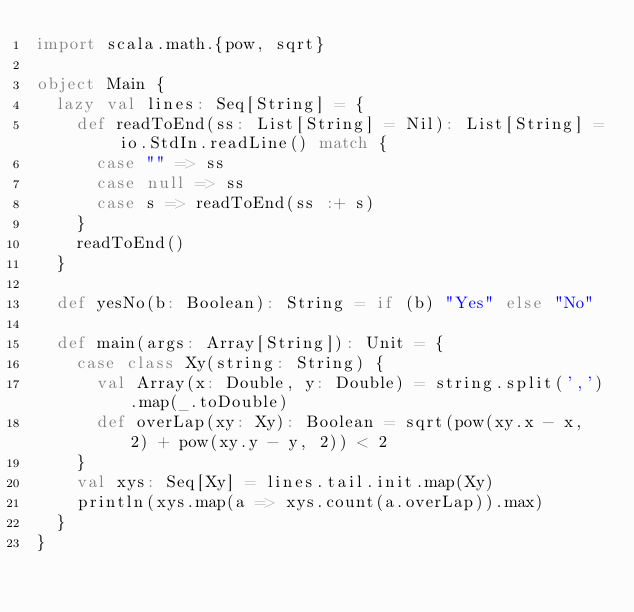<code> <loc_0><loc_0><loc_500><loc_500><_Scala_>import scala.math.{pow, sqrt}

object Main {
  lazy val lines: Seq[String] = {
    def readToEnd(ss: List[String] = Nil): List[String] = io.StdIn.readLine() match {
      case "" => ss
      case null => ss
      case s => readToEnd(ss :+ s)
    }
    readToEnd()
  }

  def yesNo(b: Boolean): String = if (b) "Yes" else "No"

  def main(args: Array[String]): Unit = {
    case class Xy(string: String) {
      val Array(x: Double, y: Double) = string.split(',').map(_.toDouble)
      def overLap(xy: Xy): Boolean = sqrt(pow(xy.x - x, 2) + pow(xy.y - y, 2)) < 2
    }
    val xys: Seq[Xy] = lines.tail.init.map(Xy)
    println(xys.map(a => xys.count(a.overLap)).max)
  }
}</code> 